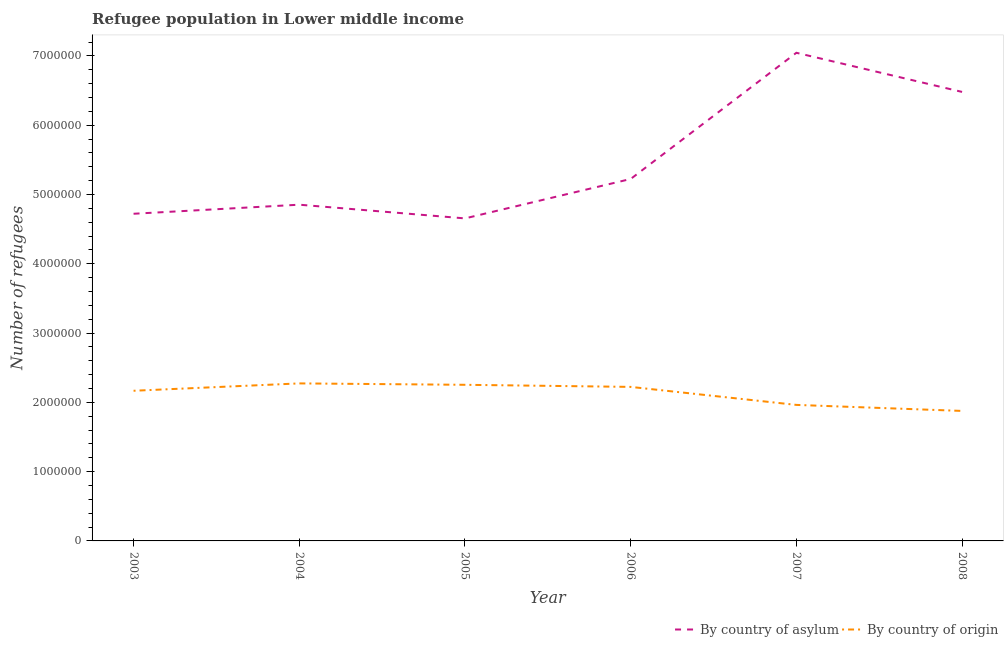Does the line corresponding to number of refugees by country of origin intersect with the line corresponding to number of refugees by country of asylum?
Give a very brief answer. No. Is the number of lines equal to the number of legend labels?
Ensure brevity in your answer.  Yes. What is the number of refugees by country of origin in 2008?
Your answer should be very brief. 1.88e+06. Across all years, what is the maximum number of refugees by country of origin?
Keep it short and to the point. 2.27e+06. Across all years, what is the minimum number of refugees by country of origin?
Give a very brief answer. 1.88e+06. In which year was the number of refugees by country of asylum minimum?
Make the answer very short. 2005. What is the total number of refugees by country of asylum in the graph?
Provide a short and direct response. 3.30e+07. What is the difference between the number of refugees by country of origin in 2007 and that in 2008?
Give a very brief answer. 8.70e+04. What is the difference between the number of refugees by country of origin in 2006 and the number of refugees by country of asylum in 2004?
Provide a succinct answer. -2.63e+06. What is the average number of refugees by country of asylum per year?
Provide a succinct answer. 5.50e+06. In the year 2004, what is the difference between the number of refugees by country of origin and number of refugees by country of asylum?
Keep it short and to the point. -2.58e+06. What is the ratio of the number of refugees by country of origin in 2004 to that in 2005?
Provide a succinct answer. 1.01. What is the difference between the highest and the second highest number of refugees by country of origin?
Provide a succinct answer. 2.02e+04. What is the difference between the highest and the lowest number of refugees by country of origin?
Give a very brief answer. 3.97e+05. In how many years, is the number of refugees by country of origin greater than the average number of refugees by country of origin taken over all years?
Your answer should be very brief. 4. Is the sum of the number of refugees by country of origin in 2003 and 2006 greater than the maximum number of refugees by country of asylum across all years?
Provide a short and direct response. No. Does the number of refugees by country of asylum monotonically increase over the years?
Provide a short and direct response. No. Is the number of refugees by country of asylum strictly greater than the number of refugees by country of origin over the years?
Make the answer very short. Yes. How many years are there in the graph?
Provide a succinct answer. 6. Are the values on the major ticks of Y-axis written in scientific E-notation?
Make the answer very short. No. Does the graph contain any zero values?
Ensure brevity in your answer.  No. How many legend labels are there?
Provide a short and direct response. 2. What is the title of the graph?
Keep it short and to the point. Refugee population in Lower middle income. Does "Depositors" appear as one of the legend labels in the graph?
Give a very brief answer. No. What is the label or title of the X-axis?
Ensure brevity in your answer.  Year. What is the label or title of the Y-axis?
Your answer should be compact. Number of refugees. What is the Number of refugees of By country of asylum in 2003?
Your answer should be very brief. 4.72e+06. What is the Number of refugees of By country of origin in 2003?
Make the answer very short. 2.17e+06. What is the Number of refugees in By country of asylum in 2004?
Provide a short and direct response. 4.85e+06. What is the Number of refugees of By country of origin in 2004?
Provide a short and direct response. 2.27e+06. What is the Number of refugees of By country of asylum in 2005?
Your response must be concise. 4.66e+06. What is the Number of refugees in By country of origin in 2005?
Offer a terse response. 2.25e+06. What is the Number of refugees in By country of asylum in 2006?
Provide a short and direct response. 5.22e+06. What is the Number of refugees of By country of origin in 2006?
Offer a terse response. 2.22e+06. What is the Number of refugees of By country of asylum in 2007?
Ensure brevity in your answer.  7.05e+06. What is the Number of refugees of By country of origin in 2007?
Offer a terse response. 1.96e+06. What is the Number of refugees in By country of asylum in 2008?
Offer a very short reply. 6.48e+06. What is the Number of refugees of By country of origin in 2008?
Offer a terse response. 1.88e+06. Across all years, what is the maximum Number of refugees in By country of asylum?
Offer a very short reply. 7.05e+06. Across all years, what is the maximum Number of refugees of By country of origin?
Provide a short and direct response. 2.27e+06. Across all years, what is the minimum Number of refugees in By country of asylum?
Your response must be concise. 4.66e+06. Across all years, what is the minimum Number of refugees in By country of origin?
Your answer should be compact. 1.88e+06. What is the total Number of refugees in By country of asylum in the graph?
Make the answer very short. 3.30e+07. What is the total Number of refugees of By country of origin in the graph?
Offer a very short reply. 1.28e+07. What is the difference between the Number of refugees of By country of asylum in 2003 and that in 2004?
Offer a very short reply. -1.31e+05. What is the difference between the Number of refugees of By country of origin in 2003 and that in 2004?
Offer a very short reply. -1.06e+05. What is the difference between the Number of refugees of By country of asylum in 2003 and that in 2005?
Keep it short and to the point. 6.69e+04. What is the difference between the Number of refugees in By country of origin in 2003 and that in 2005?
Provide a short and direct response. -8.61e+04. What is the difference between the Number of refugees in By country of asylum in 2003 and that in 2006?
Provide a succinct answer. -5.02e+05. What is the difference between the Number of refugees in By country of origin in 2003 and that in 2006?
Provide a succinct answer. -5.59e+04. What is the difference between the Number of refugees in By country of asylum in 2003 and that in 2007?
Your answer should be very brief. -2.32e+06. What is the difference between the Number of refugees in By country of origin in 2003 and that in 2007?
Offer a very short reply. 2.04e+05. What is the difference between the Number of refugees in By country of asylum in 2003 and that in 2008?
Keep it short and to the point. -1.76e+06. What is the difference between the Number of refugees of By country of origin in 2003 and that in 2008?
Make the answer very short. 2.91e+05. What is the difference between the Number of refugees in By country of asylum in 2004 and that in 2005?
Make the answer very short. 1.98e+05. What is the difference between the Number of refugees in By country of origin in 2004 and that in 2005?
Ensure brevity in your answer.  2.02e+04. What is the difference between the Number of refugees in By country of asylum in 2004 and that in 2006?
Offer a very short reply. -3.71e+05. What is the difference between the Number of refugees of By country of origin in 2004 and that in 2006?
Keep it short and to the point. 5.05e+04. What is the difference between the Number of refugees of By country of asylum in 2004 and that in 2007?
Your answer should be compact. -2.19e+06. What is the difference between the Number of refugees of By country of origin in 2004 and that in 2007?
Your answer should be compact. 3.10e+05. What is the difference between the Number of refugees in By country of asylum in 2004 and that in 2008?
Give a very brief answer. -1.63e+06. What is the difference between the Number of refugees of By country of origin in 2004 and that in 2008?
Provide a short and direct response. 3.97e+05. What is the difference between the Number of refugees in By country of asylum in 2005 and that in 2006?
Your answer should be compact. -5.69e+05. What is the difference between the Number of refugees of By country of origin in 2005 and that in 2006?
Provide a succinct answer. 3.03e+04. What is the difference between the Number of refugees in By country of asylum in 2005 and that in 2007?
Your answer should be compact. -2.39e+06. What is the difference between the Number of refugees of By country of origin in 2005 and that in 2007?
Provide a short and direct response. 2.90e+05. What is the difference between the Number of refugees of By country of asylum in 2005 and that in 2008?
Offer a very short reply. -1.83e+06. What is the difference between the Number of refugees in By country of origin in 2005 and that in 2008?
Offer a terse response. 3.77e+05. What is the difference between the Number of refugees in By country of asylum in 2006 and that in 2007?
Your answer should be compact. -1.82e+06. What is the difference between the Number of refugees in By country of origin in 2006 and that in 2007?
Your answer should be compact. 2.60e+05. What is the difference between the Number of refugees in By country of asylum in 2006 and that in 2008?
Provide a short and direct response. -1.26e+06. What is the difference between the Number of refugees in By country of origin in 2006 and that in 2008?
Keep it short and to the point. 3.47e+05. What is the difference between the Number of refugees of By country of asylum in 2007 and that in 2008?
Provide a succinct answer. 5.65e+05. What is the difference between the Number of refugees in By country of origin in 2007 and that in 2008?
Ensure brevity in your answer.  8.70e+04. What is the difference between the Number of refugees in By country of asylum in 2003 and the Number of refugees in By country of origin in 2004?
Ensure brevity in your answer.  2.45e+06. What is the difference between the Number of refugees of By country of asylum in 2003 and the Number of refugees of By country of origin in 2005?
Give a very brief answer. 2.47e+06. What is the difference between the Number of refugees in By country of asylum in 2003 and the Number of refugees in By country of origin in 2006?
Your response must be concise. 2.50e+06. What is the difference between the Number of refugees in By country of asylum in 2003 and the Number of refugees in By country of origin in 2007?
Make the answer very short. 2.76e+06. What is the difference between the Number of refugees of By country of asylum in 2003 and the Number of refugees of By country of origin in 2008?
Provide a short and direct response. 2.85e+06. What is the difference between the Number of refugees in By country of asylum in 2004 and the Number of refugees in By country of origin in 2005?
Provide a short and direct response. 2.60e+06. What is the difference between the Number of refugees in By country of asylum in 2004 and the Number of refugees in By country of origin in 2006?
Give a very brief answer. 2.63e+06. What is the difference between the Number of refugees of By country of asylum in 2004 and the Number of refugees of By country of origin in 2007?
Ensure brevity in your answer.  2.89e+06. What is the difference between the Number of refugees in By country of asylum in 2004 and the Number of refugees in By country of origin in 2008?
Offer a very short reply. 2.98e+06. What is the difference between the Number of refugees in By country of asylum in 2005 and the Number of refugees in By country of origin in 2006?
Offer a very short reply. 2.43e+06. What is the difference between the Number of refugees of By country of asylum in 2005 and the Number of refugees of By country of origin in 2007?
Your answer should be very brief. 2.69e+06. What is the difference between the Number of refugees of By country of asylum in 2005 and the Number of refugees of By country of origin in 2008?
Give a very brief answer. 2.78e+06. What is the difference between the Number of refugees of By country of asylum in 2006 and the Number of refugees of By country of origin in 2007?
Make the answer very short. 3.26e+06. What is the difference between the Number of refugees of By country of asylum in 2006 and the Number of refugees of By country of origin in 2008?
Make the answer very short. 3.35e+06. What is the difference between the Number of refugees in By country of asylum in 2007 and the Number of refugees in By country of origin in 2008?
Your answer should be very brief. 5.17e+06. What is the average Number of refugees in By country of asylum per year?
Your answer should be very brief. 5.50e+06. What is the average Number of refugees in By country of origin per year?
Keep it short and to the point. 2.13e+06. In the year 2003, what is the difference between the Number of refugees of By country of asylum and Number of refugees of By country of origin?
Your response must be concise. 2.55e+06. In the year 2004, what is the difference between the Number of refugees in By country of asylum and Number of refugees in By country of origin?
Keep it short and to the point. 2.58e+06. In the year 2005, what is the difference between the Number of refugees of By country of asylum and Number of refugees of By country of origin?
Offer a very short reply. 2.40e+06. In the year 2006, what is the difference between the Number of refugees of By country of asylum and Number of refugees of By country of origin?
Ensure brevity in your answer.  3.00e+06. In the year 2007, what is the difference between the Number of refugees in By country of asylum and Number of refugees in By country of origin?
Provide a short and direct response. 5.08e+06. In the year 2008, what is the difference between the Number of refugees in By country of asylum and Number of refugees in By country of origin?
Provide a short and direct response. 4.60e+06. What is the ratio of the Number of refugees of By country of asylum in 2003 to that in 2004?
Make the answer very short. 0.97. What is the ratio of the Number of refugees in By country of origin in 2003 to that in 2004?
Offer a terse response. 0.95. What is the ratio of the Number of refugees of By country of asylum in 2003 to that in 2005?
Make the answer very short. 1.01. What is the ratio of the Number of refugees in By country of origin in 2003 to that in 2005?
Keep it short and to the point. 0.96. What is the ratio of the Number of refugees of By country of asylum in 2003 to that in 2006?
Your answer should be very brief. 0.9. What is the ratio of the Number of refugees of By country of origin in 2003 to that in 2006?
Your response must be concise. 0.97. What is the ratio of the Number of refugees in By country of asylum in 2003 to that in 2007?
Offer a terse response. 0.67. What is the ratio of the Number of refugees of By country of origin in 2003 to that in 2007?
Offer a terse response. 1.1. What is the ratio of the Number of refugees of By country of asylum in 2003 to that in 2008?
Offer a very short reply. 0.73. What is the ratio of the Number of refugees in By country of origin in 2003 to that in 2008?
Ensure brevity in your answer.  1.16. What is the ratio of the Number of refugees in By country of asylum in 2004 to that in 2005?
Your answer should be compact. 1.04. What is the ratio of the Number of refugees in By country of asylum in 2004 to that in 2006?
Keep it short and to the point. 0.93. What is the ratio of the Number of refugees of By country of origin in 2004 to that in 2006?
Offer a terse response. 1.02. What is the ratio of the Number of refugees in By country of asylum in 2004 to that in 2007?
Offer a terse response. 0.69. What is the ratio of the Number of refugees in By country of origin in 2004 to that in 2007?
Your answer should be compact. 1.16. What is the ratio of the Number of refugees of By country of asylum in 2004 to that in 2008?
Keep it short and to the point. 0.75. What is the ratio of the Number of refugees in By country of origin in 2004 to that in 2008?
Provide a short and direct response. 1.21. What is the ratio of the Number of refugees of By country of asylum in 2005 to that in 2006?
Your answer should be compact. 0.89. What is the ratio of the Number of refugees of By country of origin in 2005 to that in 2006?
Provide a short and direct response. 1.01. What is the ratio of the Number of refugees in By country of asylum in 2005 to that in 2007?
Provide a short and direct response. 0.66. What is the ratio of the Number of refugees of By country of origin in 2005 to that in 2007?
Your response must be concise. 1.15. What is the ratio of the Number of refugees of By country of asylum in 2005 to that in 2008?
Make the answer very short. 0.72. What is the ratio of the Number of refugees in By country of origin in 2005 to that in 2008?
Provide a short and direct response. 1.2. What is the ratio of the Number of refugees in By country of asylum in 2006 to that in 2007?
Your answer should be compact. 0.74. What is the ratio of the Number of refugees in By country of origin in 2006 to that in 2007?
Provide a short and direct response. 1.13. What is the ratio of the Number of refugees in By country of asylum in 2006 to that in 2008?
Your answer should be compact. 0.81. What is the ratio of the Number of refugees of By country of origin in 2006 to that in 2008?
Make the answer very short. 1.18. What is the ratio of the Number of refugees in By country of asylum in 2007 to that in 2008?
Make the answer very short. 1.09. What is the ratio of the Number of refugees of By country of origin in 2007 to that in 2008?
Your answer should be compact. 1.05. What is the difference between the highest and the second highest Number of refugees of By country of asylum?
Offer a very short reply. 5.65e+05. What is the difference between the highest and the second highest Number of refugees of By country of origin?
Offer a terse response. 2.02e+04. What is the difference between the highest and the lowest Number of refugees in By country of asylum?
Give a very brief answer. 2.39e+06. What is the difference between the highest and the lowest Number of refugees in By country of origin?
Give a very brief answer. 3.97e+05. 